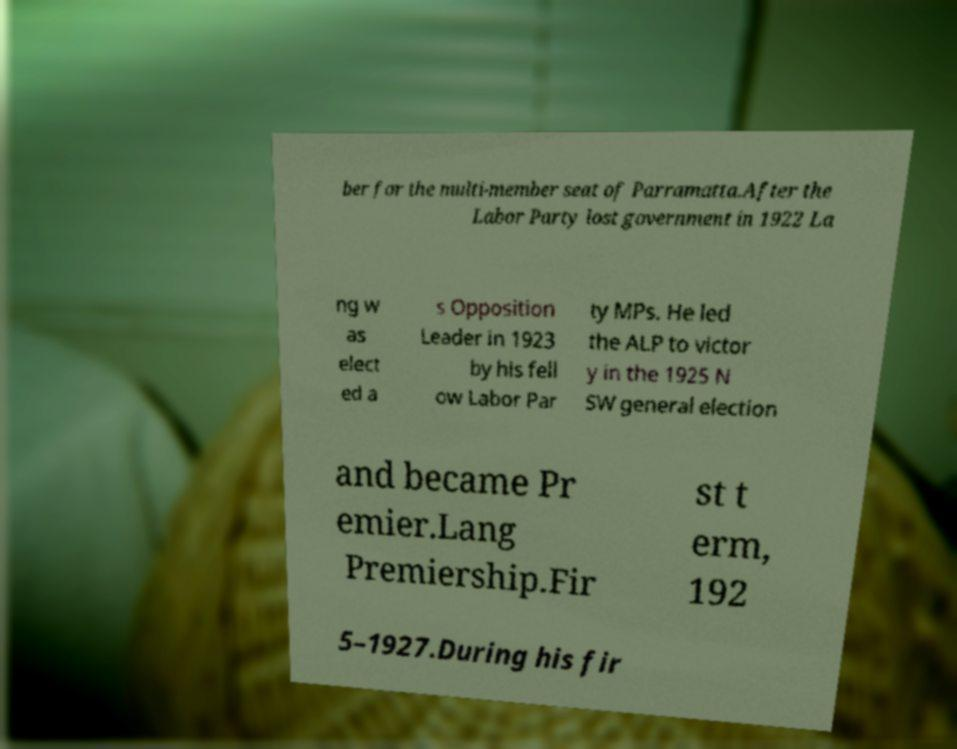For documentation purposes, I need the text within this image transcribed. Could you provide that? ber for the multi-member seat of Parramatta.After the Labor Party lost government in 1922 La ng w as elect ed a s Opposition Leader in 1923 by his fell ow Labor Par ty MPs. He led the ALP to victor y in the 1925 N SW general election and became Pr emier.Lang Premiership.Fir st t erm, 192 5–1927.During his fir 